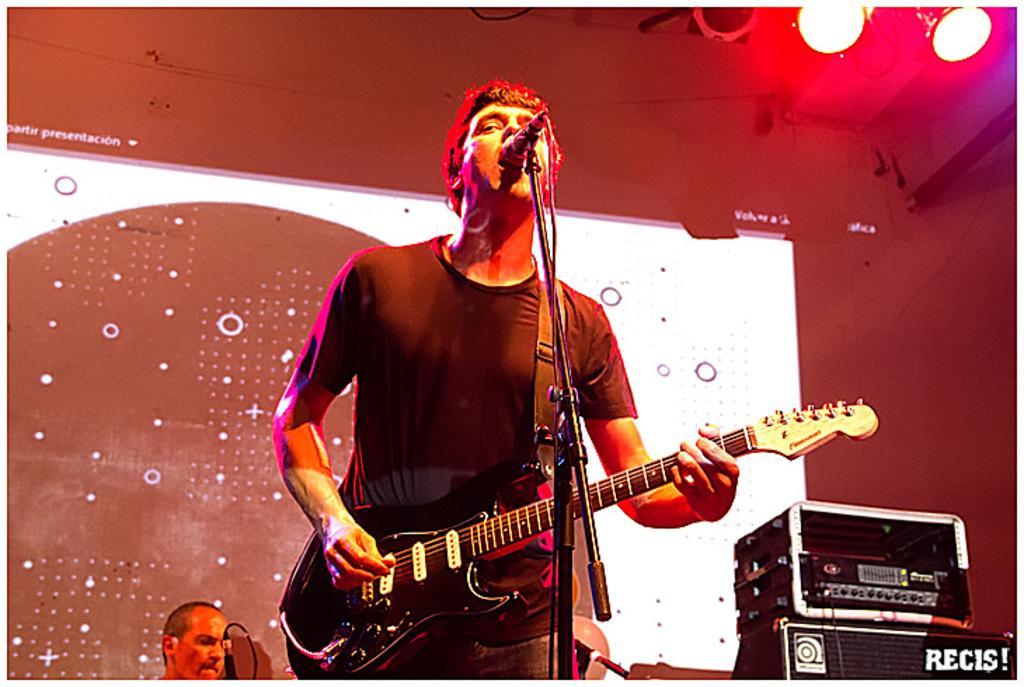Could you give a brief overview of what you see in this image? In this image I see a man who is holding a guitar and standing in front of a mic and in the background I see a person, the wall and 2 lights. 